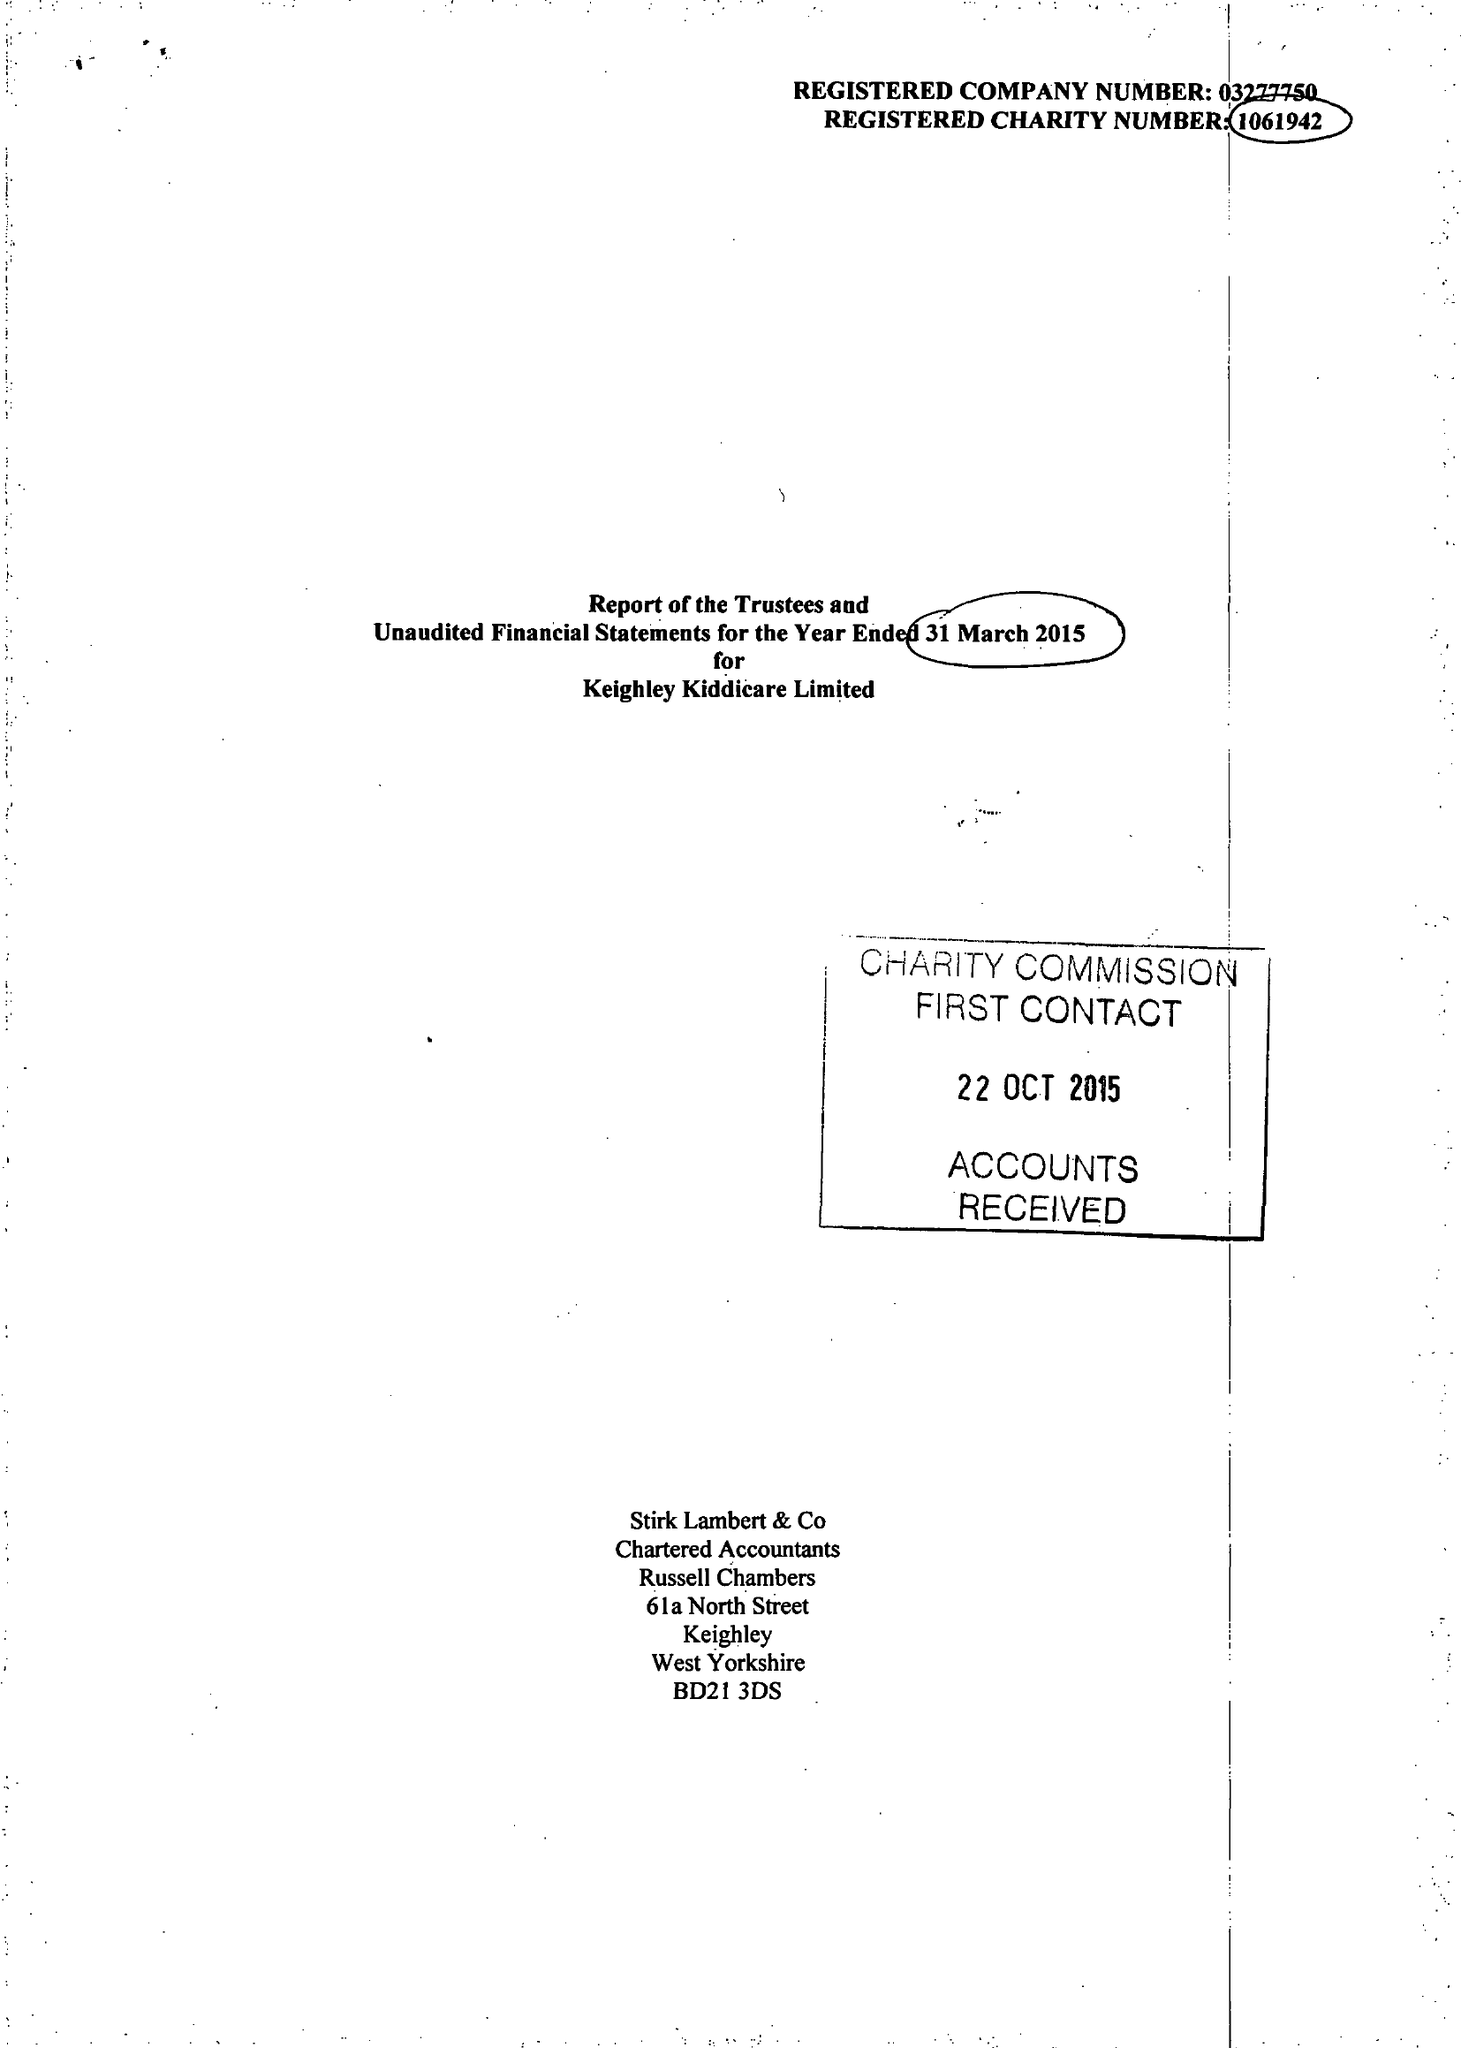What is the value for the report_date?
Answer the question using a single word or phrase. 2015-03-31 